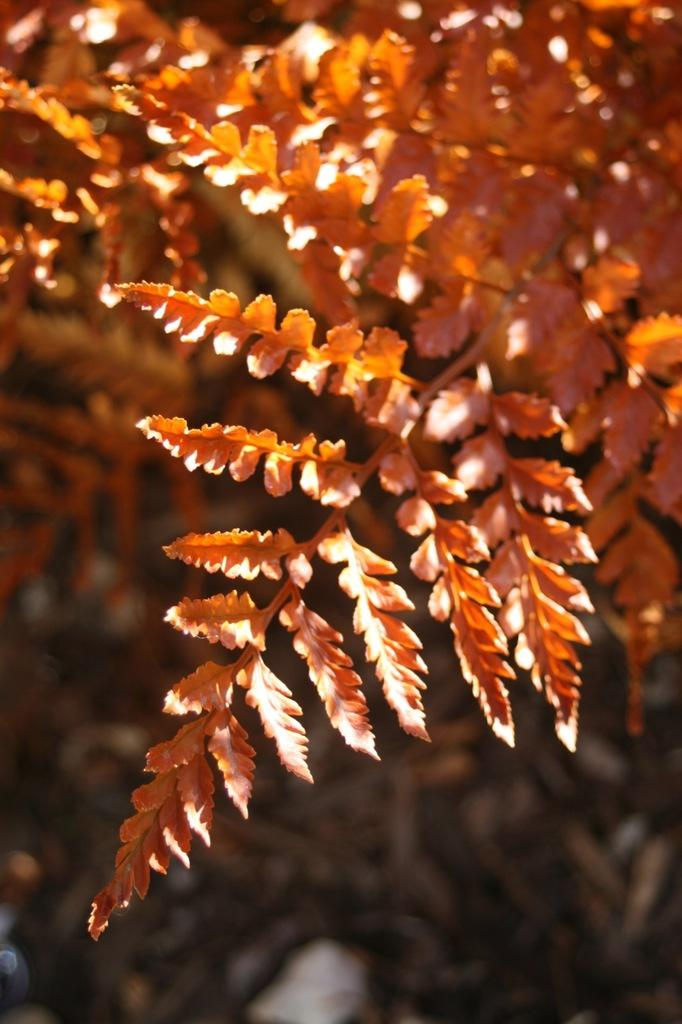What is the main subject of the image? There is a tree in the image. What color is the tree? The tree is orange in color. Can you describe the background of the image? The background of the image is blurry. What type of mask is the tree wearing in the image? There is no mask present on the tree in the image. How many grains of rice can be seen on the tree in the image? There is no rice present on the tree in the image. 